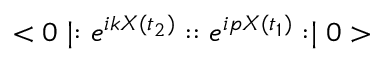<formula> <loc_0><loc_0><loc_500><loc_500>< 0 | \colon e ^ { i k X ( t _ { 2 } ) } \colon \colon e ^ { i p X ( t _ { 1 } ) } \colon | 0 ></formula> 